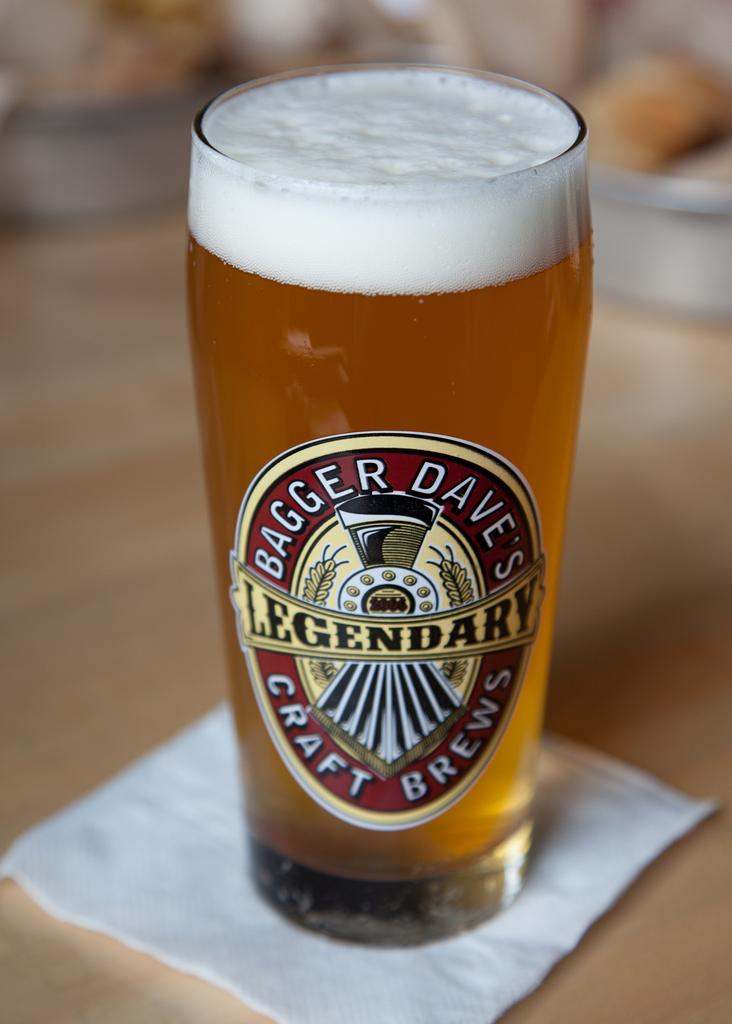What is in the glass that is visible in the image? There is a drink in the glass in the image. What other item can be seen on the table in the image? There is a tissue on the table in the image. Can you describe the background of the image? The background of the image is blurry. What type of calendar is hanging on the roof in the image? There is no calendar or roof present in the image. 